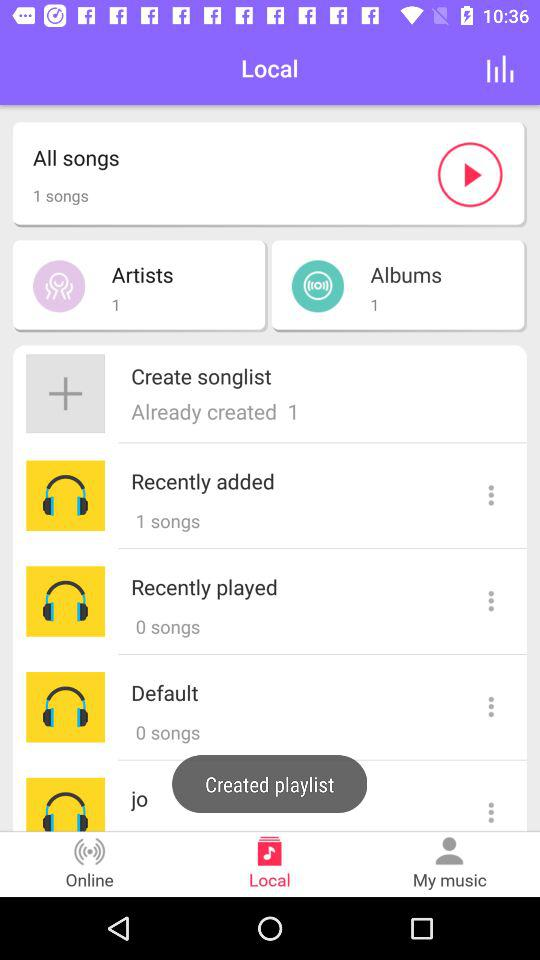What tab am I on? You are on "Local" tab. 